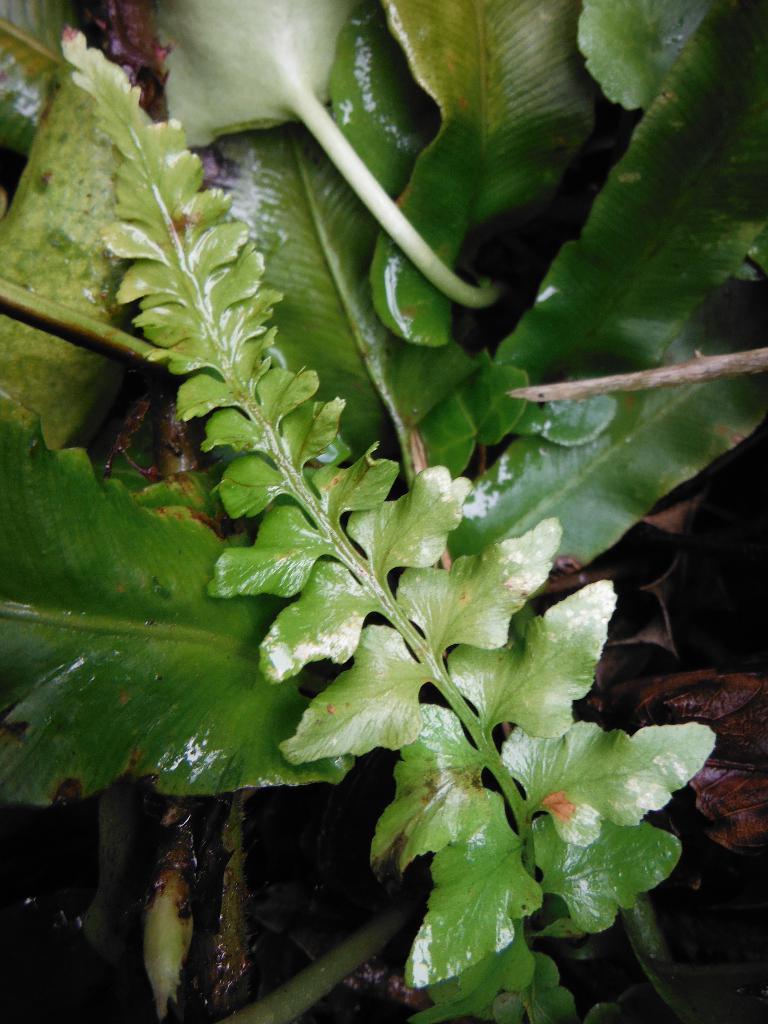Could you give a brief overview of what you see in this image? This is the picture of a plant. There are leaves on the plant. 